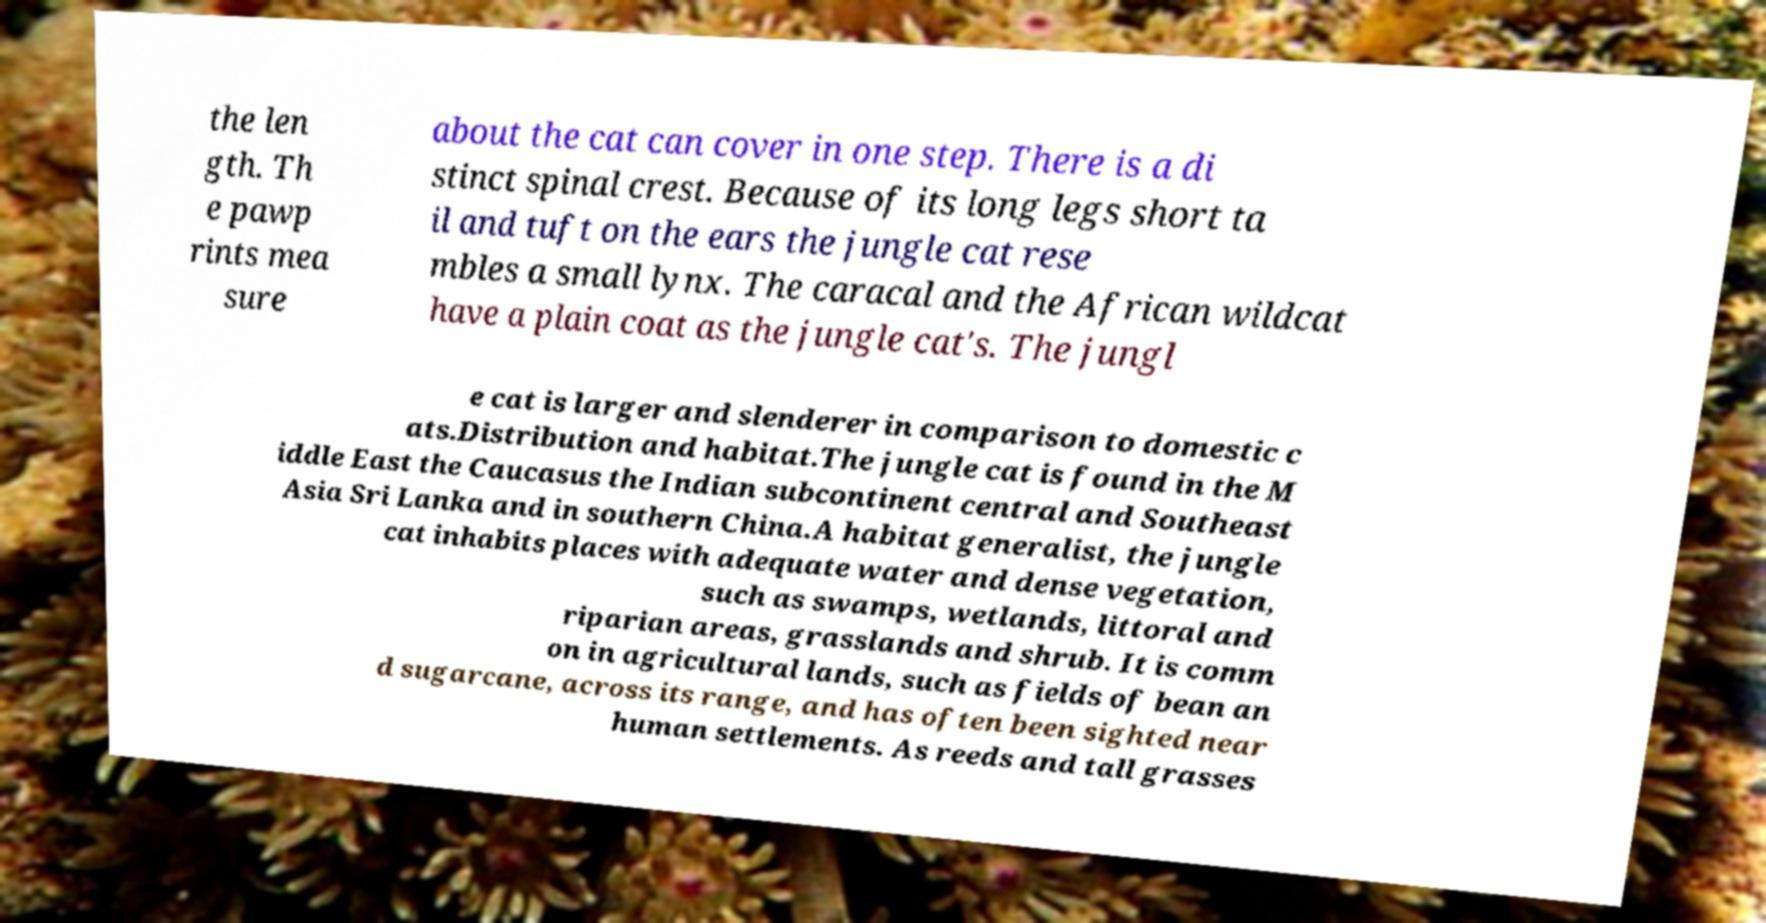Can you accurately transcribe the text from the provided image for me? the len gth. Th e pawp rints mea sure about the cat can cover in one step. There is a di stinct spinal crest. Because of its long legs short ta il and tuft on the ears the jungle cat rese mbles a small lynx. The caracal and the African wildcat have a plain coat as the jungle cat's. The jungl e cat is larger and slenderer in comparison to domestic c ats.Distribution and habitat.The jungle cat is found in the M iddle East the Caucasus the Indian subcontinent central and Southeast Asia Sri Lanka and in southern China.A habitat generalist, the jungle cat inhabits places with adequate water and dense vegetation, such as swamps, wetlands, littoral and riparian areas, grasslands and shrub. It is comm on in agricultural lands, such as fields of bean an d sugarcane, across its range, and has often been sighted near human settlements. As reeds and tall grasses 